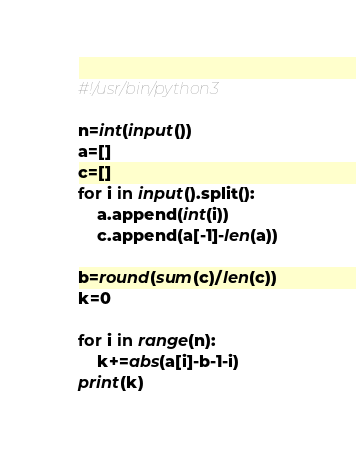Convert code to text. <code><loc_0><loc_0><loc_500><loc_500><_Python_>#!/usr/bin/python3

n=int(input())
a=[]
c=[]
for i in input().split():
    a.append(int(i))
    c.append(a[-1]-len(a))

b=round(sum(c)/len(c))
k=0

for i in range(n):
    k+=abs(a[i]-b-1-i)
print(k)</code> 